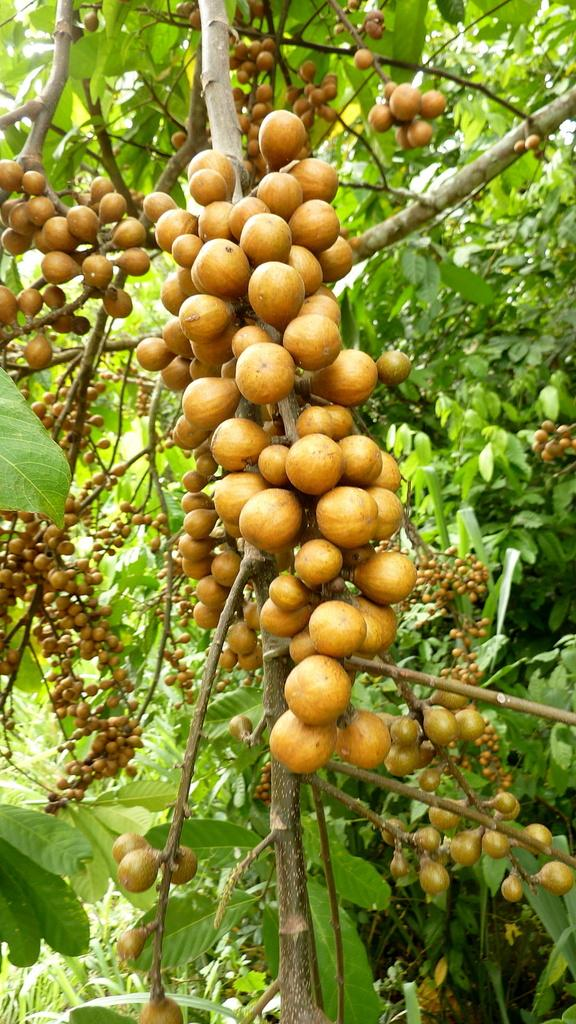What type of trees are present in the image? There are fruit trees in the image. Where might this image have been taken? The image may have been taken on a farm. What time of day was the image likely taken? The image was likely taken during the day. What type of acoustics can be heard in the image? There are no sounds or acoustics present in the image, as it is a still photograph. 